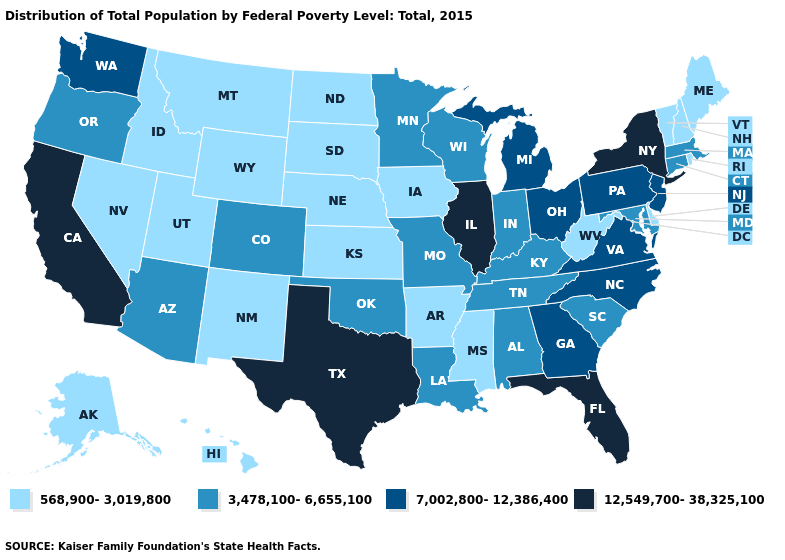What is the value of Virginia?
Quick response, please. 7,002,800-12,386,400. Which states hav the highest value in the MidWest?
Short answer required. Illinois. What is the value of New York?
Concise answer only. 12,549,700-38,325,100. Name the states that have a value in the range 12,549,700-38,325,100?
Keep it brief. California, Florida, Illinois, New York, Texas. Name the states that have a value in the range 12,549,700-38,325,100?
Keep it brief. California, Florida, Illinois, New York, Texas. Among the states that border Wisconsin , which have the lowest value?
Keep it brief. Iowa. Does Colorado have the lowest value in the USA?
Short answer required. No. Name the states that have a value in the range 568,900-3,019,800?
Quick response, please. Alaska, Arkansas, Delaware, Hawaii, Idaho, Iowa, Kansas, Maine, Mississippi, Montana, Nebraska, Nevada, New Hampshire, New Mexico, North Dakota, Rhode Island, South Dakota, Utah, Vermont, West Virginia, Wyoming. What is the value of Connecticut?
Be succinct. 3,478,100-6,655,100. Which states have the lowest value in the USA?
Quick response, please. Alaska, Arkansas, Delaware, Hawaii, Idaho, Iowa, Kansas, Maine, Mississippi, Montana, Nebraska, Nevada, New Hampshire, New Mexico, North Dakota, Rhode Island, South Dakota, Utah, Vermont, West Virginia, Wyoming. Does Georgia have the highest value in the South?
Keep it brief. No. Name the states that have a value in the range 7,002,800-12,386,400?
Keep it brief. Georgia, Michigan, New Jersey, North Carolina, Ohio, Pennsylvania, Virginia, Washington. Does California have the highest value in the West?
Give a very brief answer. Yes. Name the states that have a value in the range 7,002,800-12,386,400?
Concise answer only. Georgia, Michigan, New Jersey, North Carolina, Ohio, Pennsylvania, Virginia, Washington. Which states have the lowest value in the South?
Short answer required. Arkansas, Delaware, Mississippi, West Virginia. 